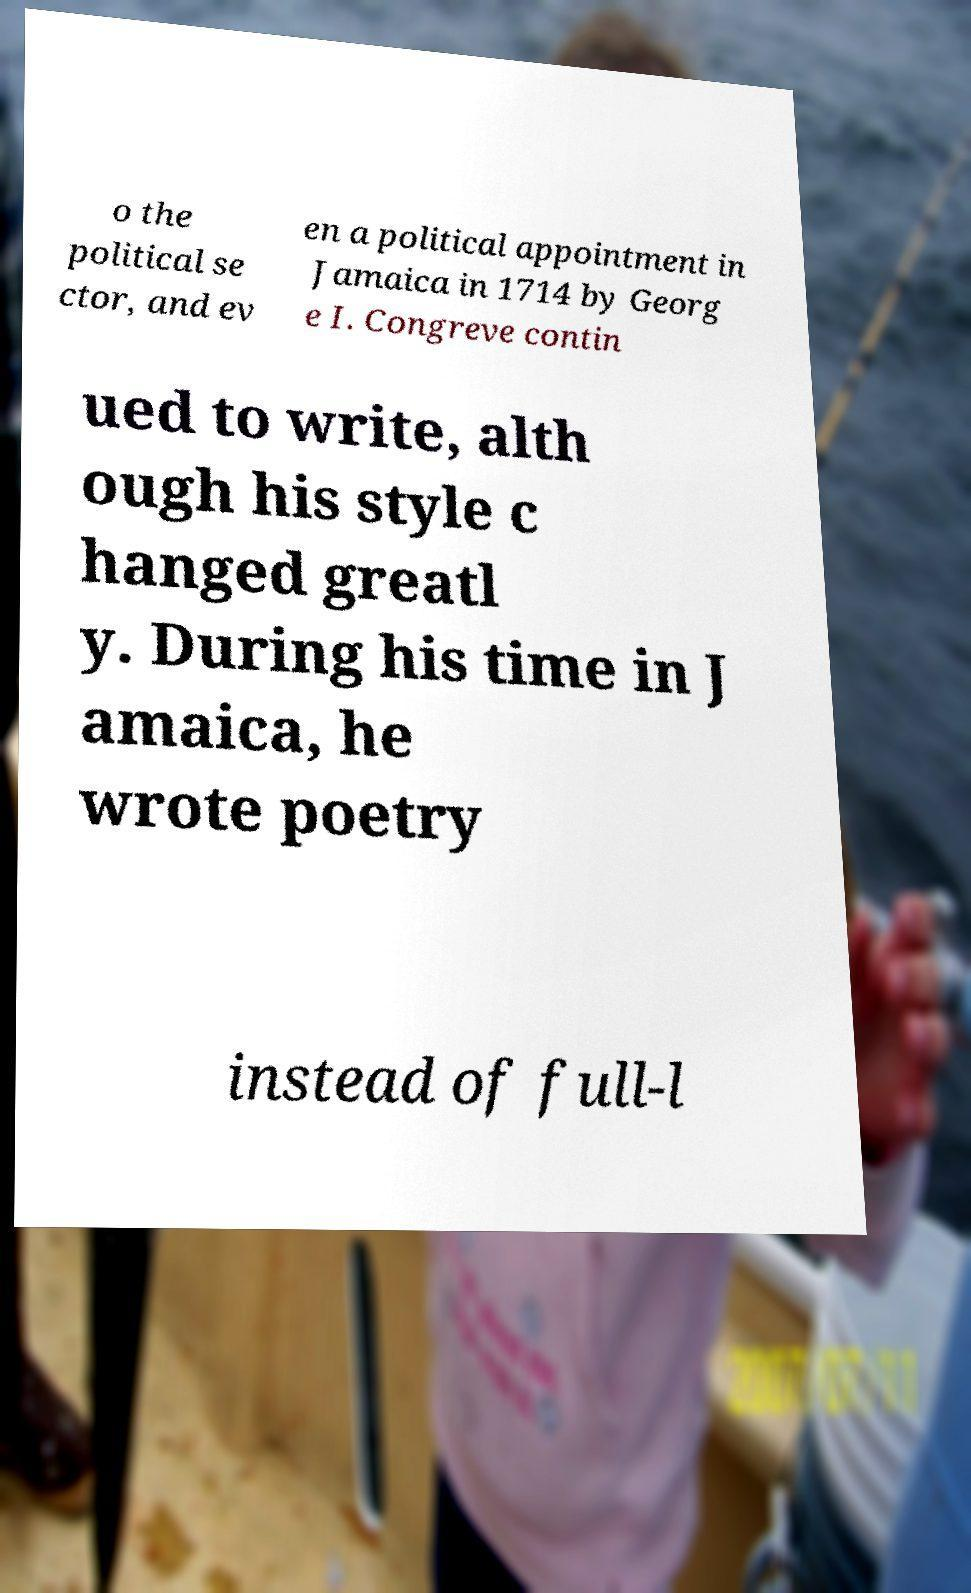Can you accurately transcribe the text from the provided image for me? o the political se ctor, and ev en a political appointment in Jamaica in 1714 by Georg e I. Congreve contin ued to write, alth ough his style c hanged greatl y. During his time in J amaica, he wrote poetry instead of full-l 